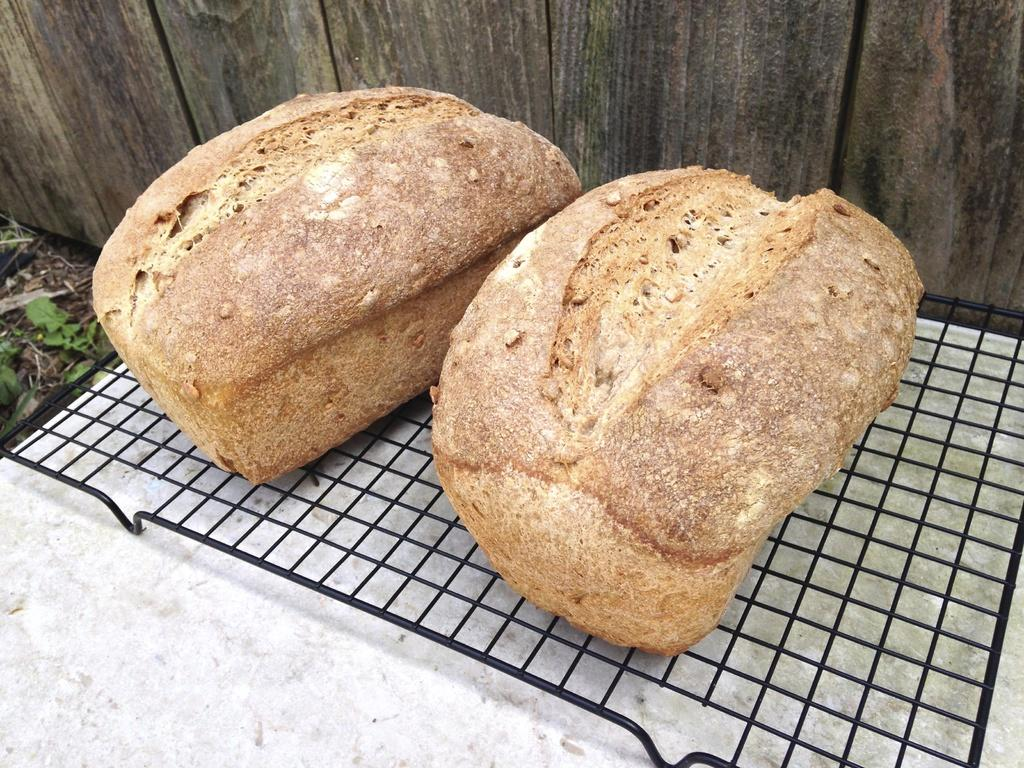What type of food can be seen in the image? There are loaves of bread in the image. How are the loaves of bread being prepared? The loaves of bread are on a grill. What can be seen in the background of the image? There is a wall in the background of the image. What type of flag is visible on the loaves of bread in the image? There is no flag present on the loaves of bread in the image. 